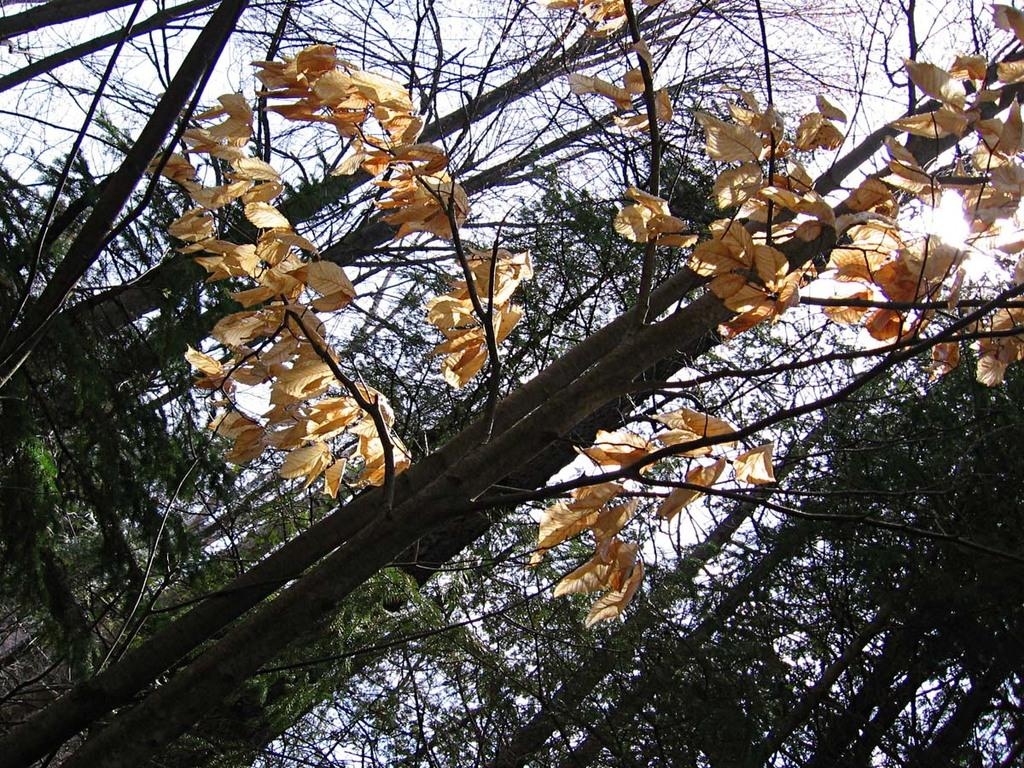What is in the foreground of the image? There are leaves in the foreground of the image. To which plant do the leaves belong? The leaves belong to a tree. What can be seen in the background of the image? There are trees and the sky visible in the background of the image. What type of tail can be seen on the tree in the image? There is no tail present on the tree in the image. 